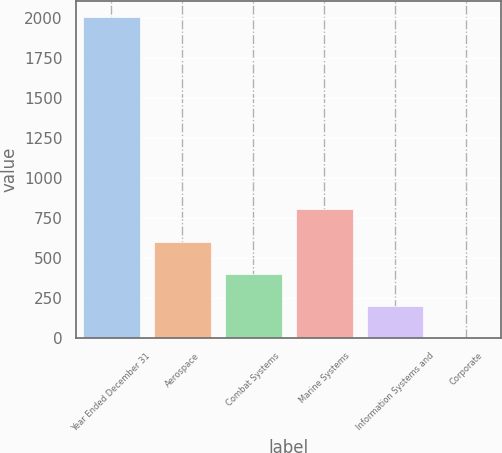<chart> <loc_0><loc_0><loc_500><loc_500><bar_chart><fcel>Year Ended December 31<fcel>Aerospace<fcel>Combat Systems<fcel>Marine Systems<fcel>Information Systems and<fcel>Corporate<nl><fcel>2007<fcel>604.2<fcel>403.8<fcel>804.6<fcel>203.4<fcel>3<nl></chart> 